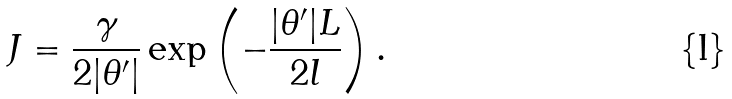<formula> <loc_0><loc_0><loc_500><loc_500>J = \frac { \gamma } { 2 | \theta ^ { \prime } | } \exp \left ( - \frac { | \theta ^ { \prime } | L } { 2 l } \right ) .</formula> 